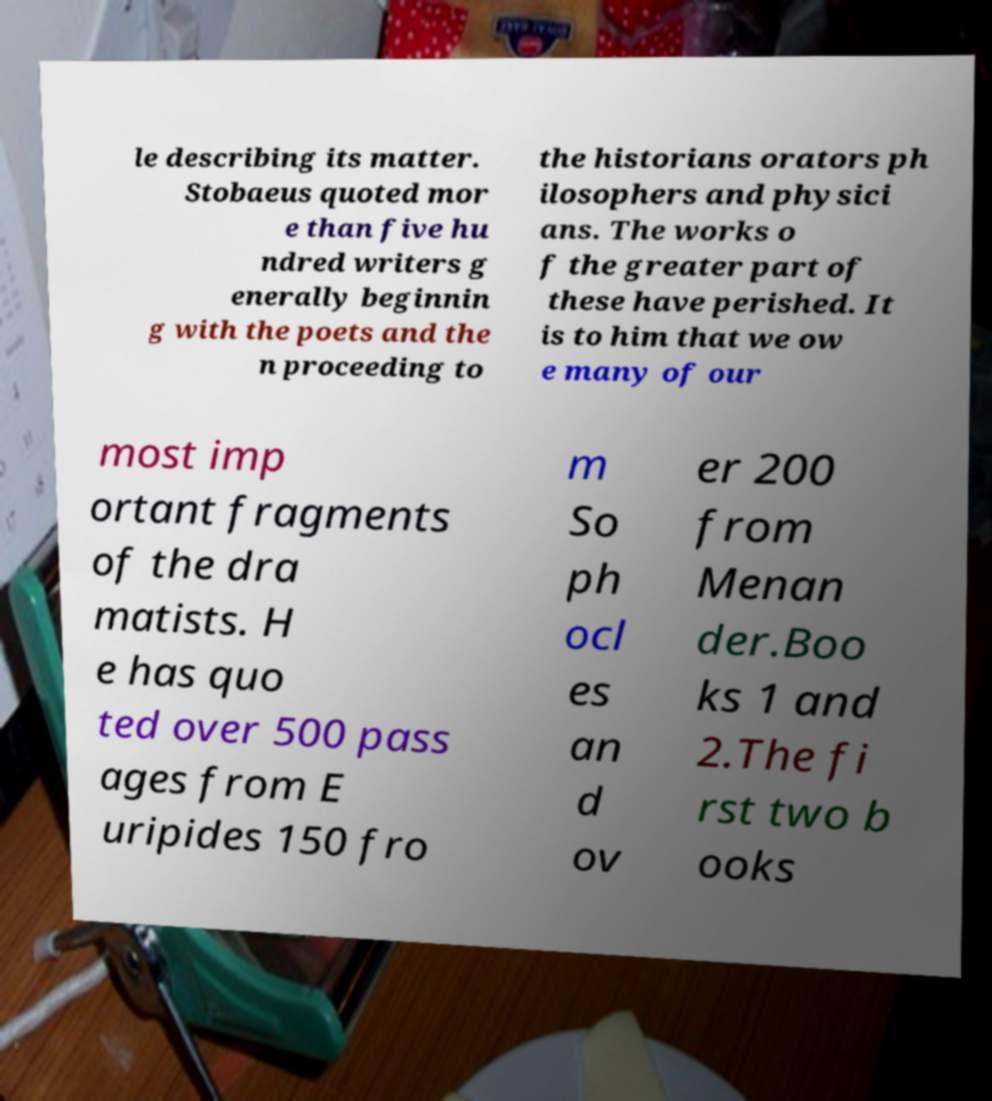Could you extract and type out the text from this image? le describing its matter. Stobaeus quoted mor e than five hu ndred writers g enerally beginnin g with the poets and the n proceeding to the historians orators ph ilosophers and physici ans. The works o f the greater part of these have perished. It is to him that we ow e many of our most imp ortant fragments of the dra matists. H e has quo ted over 500 pass ages from E uripides 150 fro m So ph ocl es an d ov er 200 from Menan der.Boo ks 1 and 2.The fi rst two b ooks 